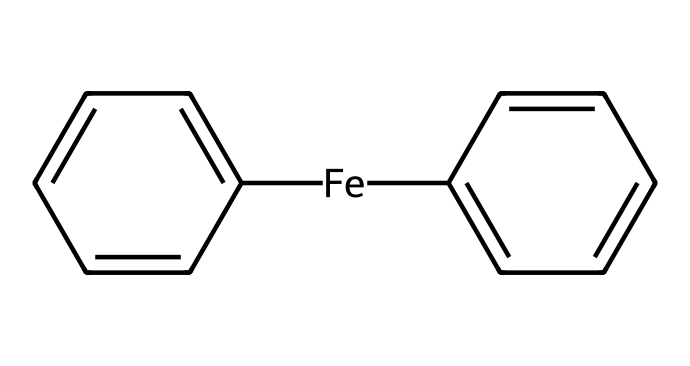What is the central metal in the structure of ferrocene? The chemical structure shows an iron atom centrally located within the compound. This is indicated by the presence of the [Fe] in the SMILES representation, which denotes iron as a metal center.
Answer: iron How many cyclopentadienyl rings are present in ferrocene? The structure includes two instances of a cyclopentadienyl ring, as indicated by the two C1=CC=CC=C1 sections in the SMILES, each representing one cyclopentadienyl ligand.
Answer: two What type of bonding is primarily present between the iron and cyclopentadienyl rings in ferrocene? The bonding type indicated in the structure involves a metal-carbon bond. Given that the iron is bonded to carbon atoms from both cyclopentadienyl rings, it shows coordination between the metal and ligands.
Answer: metal-carbon bond What is the hybridization of the iron atom in ferrocene? In ferrocene, the iron atom exhibits a hybridization state consistent with its bonding to the two cyclopentadienyl anions, which is typically considered to be d2sp3 hybridization due to its coordination geometry involving both σ and π interactions.
Answer: d2sp3 Why is ferrocene considered an organometallic compound? Ferrocene is termed an organometallic compound due to the presence of both metal (iron) and organic components (the cyclopentadienyl rings), reflecting the characteristics of organometallic chemistry that involves the bonding of metals to organic moieties.
Answer: it contains metal and organic components How does the structure of ferrocene contribute to its stability? The “sandwich” structure formed by the two cyclopentadienyl rings provides extensive delocalization of π electrons, which stabilizes the system. This configuration also allows for favorable interactions between the metal center and the ligands, enhancing stability.
Answer: extensive delocalization of π electrons 